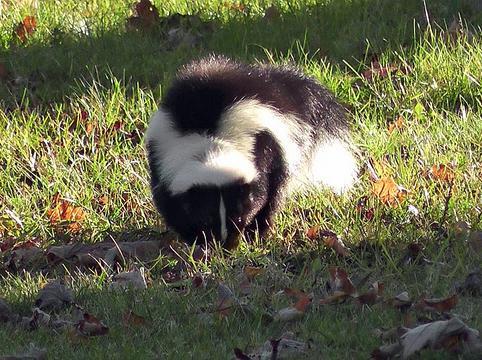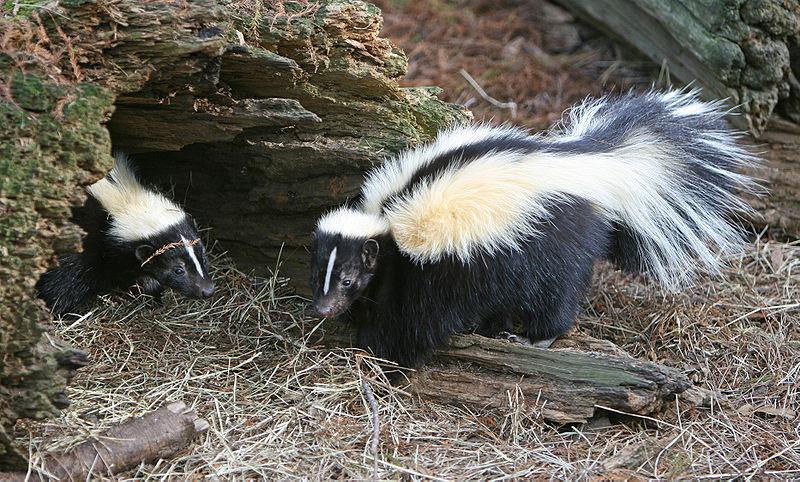The first image is the image on the left, the second image is the image on the right. Assess this claim about the two images: "The left image contains one forward-facing skunk, and the right image includes a skunk on all fours with its body turned leftward.". Correct or not? Answer yes or no. Yes. The first image is the image on the left, the second image is the image on the right. Given the left and right images, does the statement "At least one skunk is in the grass." hold true? Answer yes or no. Yes. 